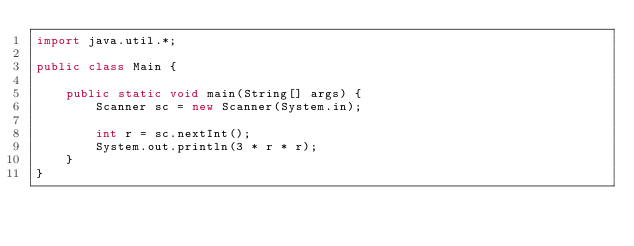<code> <loc_0><loc_0><loc_500><loc_500><_Java_>import java.util.*;

public class Main {
	
    public static void main(String[] args) {
        Scanner sc = new Scanner(System.in);
        
        int r = sc.nextInt();
        System.out.println(3 * r * r);
    }
}</code> 